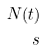Convert formula to latex. <formula><loc_0><loc_0><loc_500><loc_500>N ( t ) \\ s</formula> 